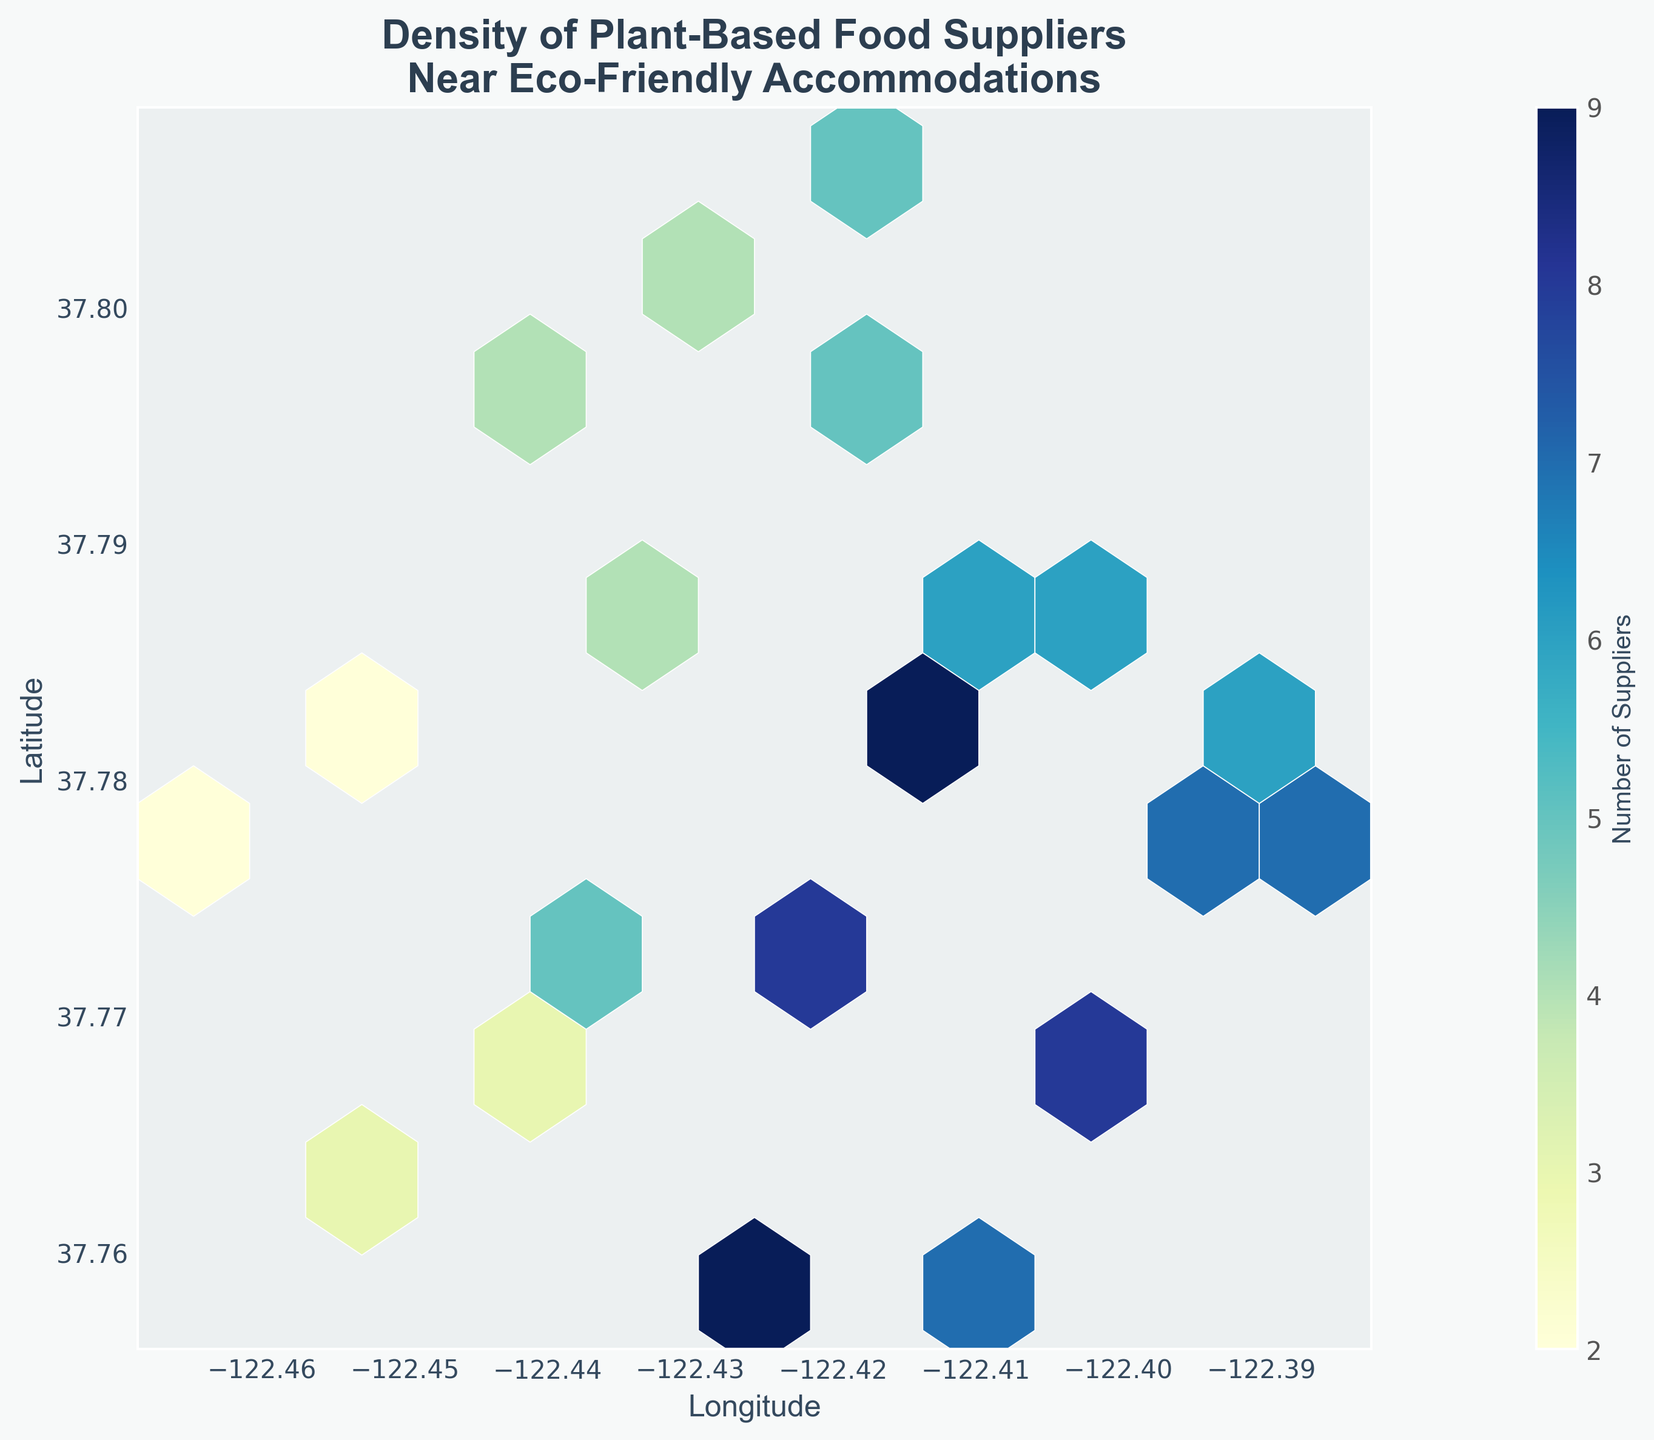What's the title of the figure? The title is usually found at the top of the figure. In this case, it reads "Density of Plant-Based Food Suppliers Near Eco-Friendly Accommodations."
Answer: "Density of Plant-Based Food Suppliers Near Eco-Friendly Accommodations" What does the color bar represent? The color bar typically explains the gradient of colors used in the hexbin plot. Here, it represents the "Number of Suppliers." This indicates how many plant-based food suppliers are in each hexagon.
Answer: Number of Suppliers What does a darker hexagon signify in the plot? In the hexbin plot, darker hexagons indicate a higher density or number of plant-based food suppliers. The color gradient from light to dark usually signifies an increase in density.
Answer: Higher density of suppliers Where is the highest concentration of plant-based food suppliers located geographically? To identify the highest concentration, look for the darkest hexagon in the plot. It is located around the central coordinates where the longitude and latitude indicate the center of San Francisco.
Answer: Around central San Francisco Between which longitude and latitude do we see the lowest density of suppliers? The lightest or most transparent hexagons indicate the lowest density. These hexagons are found on the outskirts of the hexbin plot, particularly around the highest and lowest values of longitude and latitude.
Answer: Outskirts of the plot How many suppliers are near the coordinates (-122.4108, 37.7858)? To find this, locate the hexagon nearest to the given coordinates. According to the data, there are 6 suppliers near these coordinates.
Answer: 6 suppliers What can you infer about the general trend of supplier density in relation to longitude and latitude? By observing the hexbin plot, we see a central cluster of darker hexagons, indicating higher supplier density. The density decreases as we move away from this central cluster. Thus, most suppliers are concentrated centrally and fewer are found on the outskirts.
Answer: Higher density in the central area, lower on the outskirts Which areas have a density of 2 suppliers? Areas with 2 suppliers can be identified from specific hexagons on the plot. According to the data, hexagons around coordinates (-122.4569, 37.7811) and (-122.4648, 37.7749) have this density.
Answer: Around (-122.4569, 37.7811) and (-122.4648, 37.7749) Compare the number of suppliers located at (37.7831, -122.4121) and (37.7583, -122.4240). Which has more suppliers? Look at the hexagons near the given coordinates. The data shows that (37.7831, -122.4121) has 9 suppliers while (37.7583, -122.4240) also has 9 suppliers. Therefore, both locations have an equal number of suppliers.
Answer: Both have 9 suppliers 